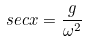<formula> <loc_0><loc_0><loc_500><loc_500>s e c x = \frac { g } { \omega ^ { 2 } }</formula> 